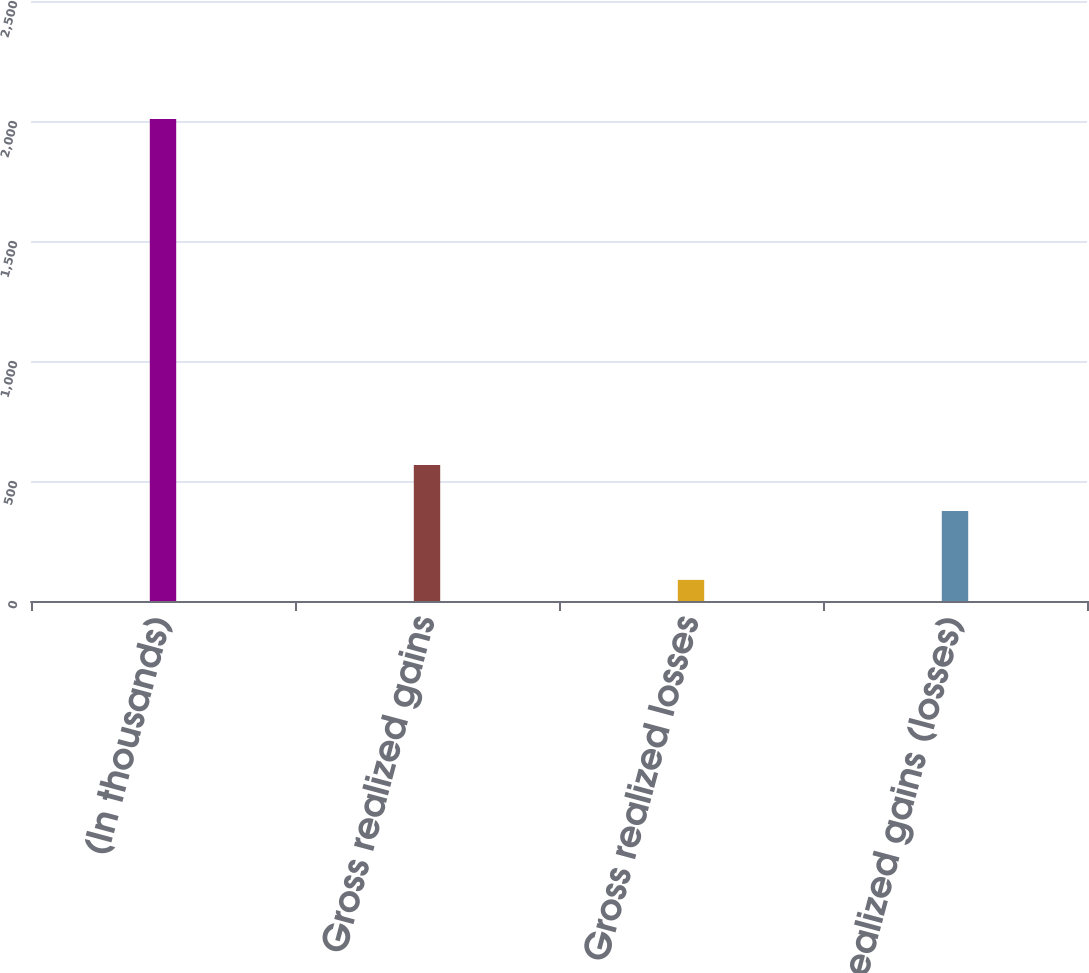<chart> <loc_0><loc_0><loc_500><loc_500><bar_chart><fcel>(In thousands)<fcel>Gross realized gains<fcel>Gross realized losses<fcel>Net realized gains (losses)<nl><fcel>2008<fcel>567<fcel>88<fcel>375<nl></chart> 